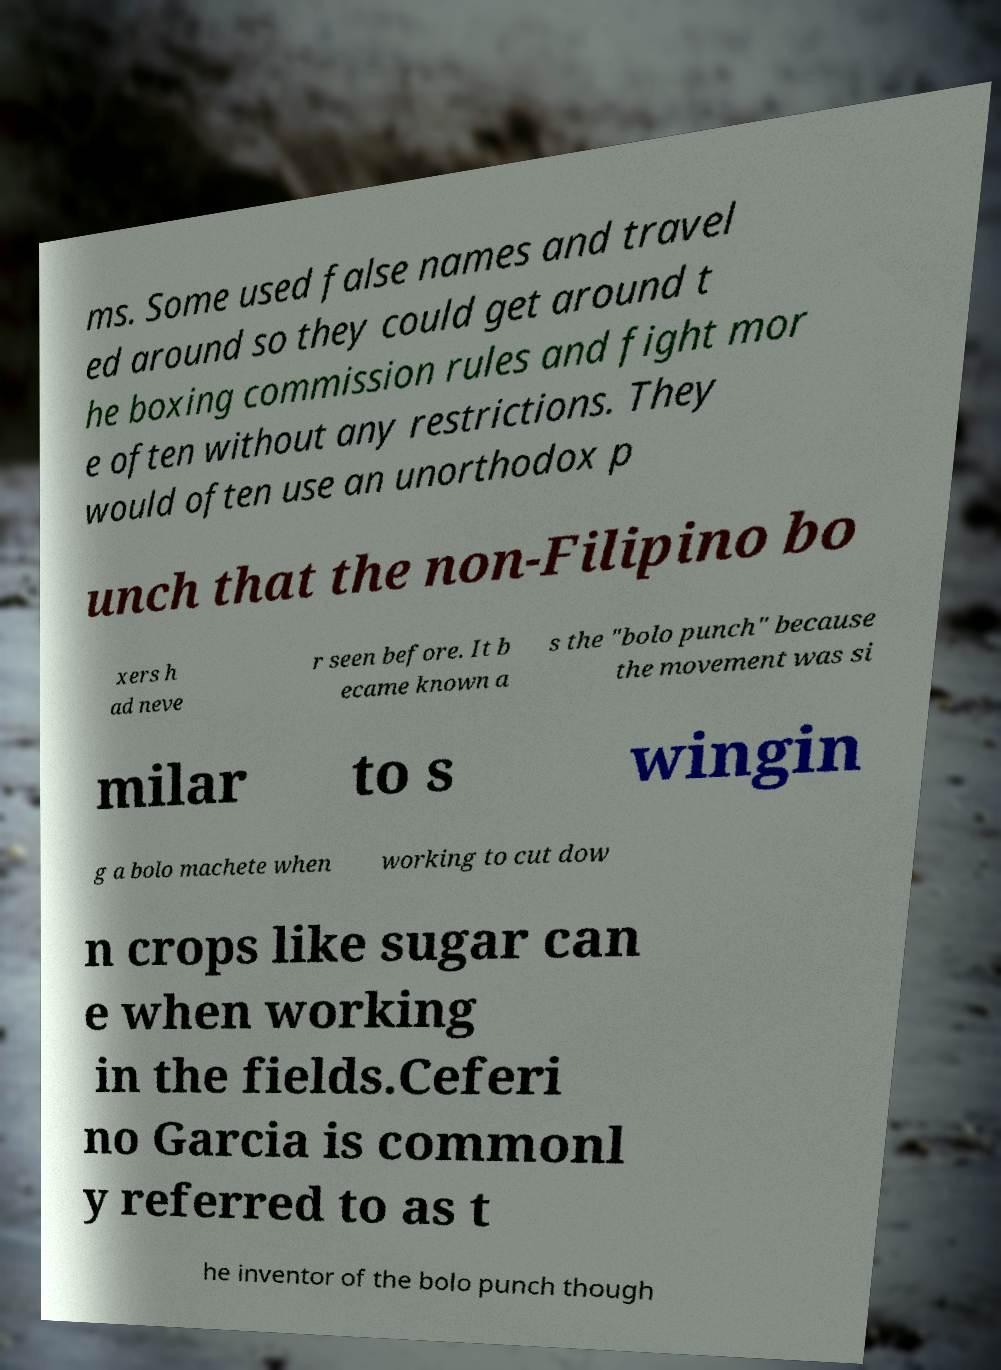For documentation purposes, I need the text within this image transcribed. Could you provide that? ms. Some used false names and travel ed around so they could get around t he boxing commission rules and fight mor e often without any restrictions. They would often use an unorthodox p unch that the non-Filipino bo xers h ad neve r seen before. It b ecame known a s the "bolo punch" because the movement was si milar to s wingin g a bolo machete when working to cut dow n crops like sugar can e when working in the fields.Ceferi no Garcia is commonl y referred to as t he inventor of the bolo punch though 